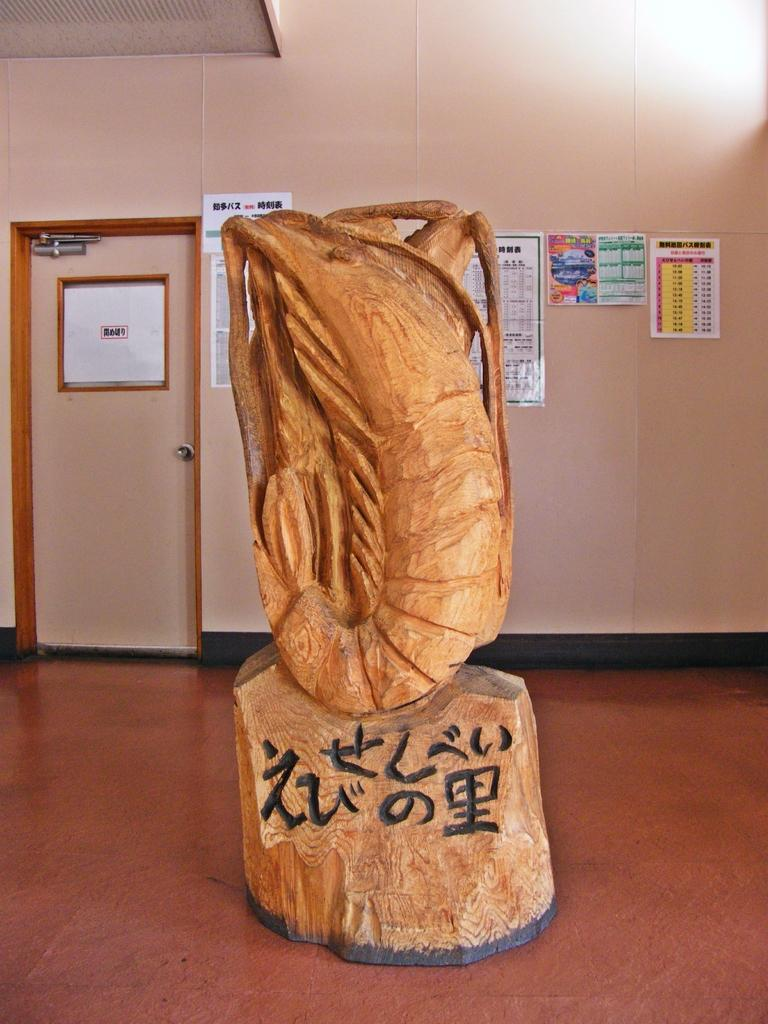<image>
Relay a brief, clear account of the picture shown. A sculpture made of wood has writing at the bottom with a sideways 6. 